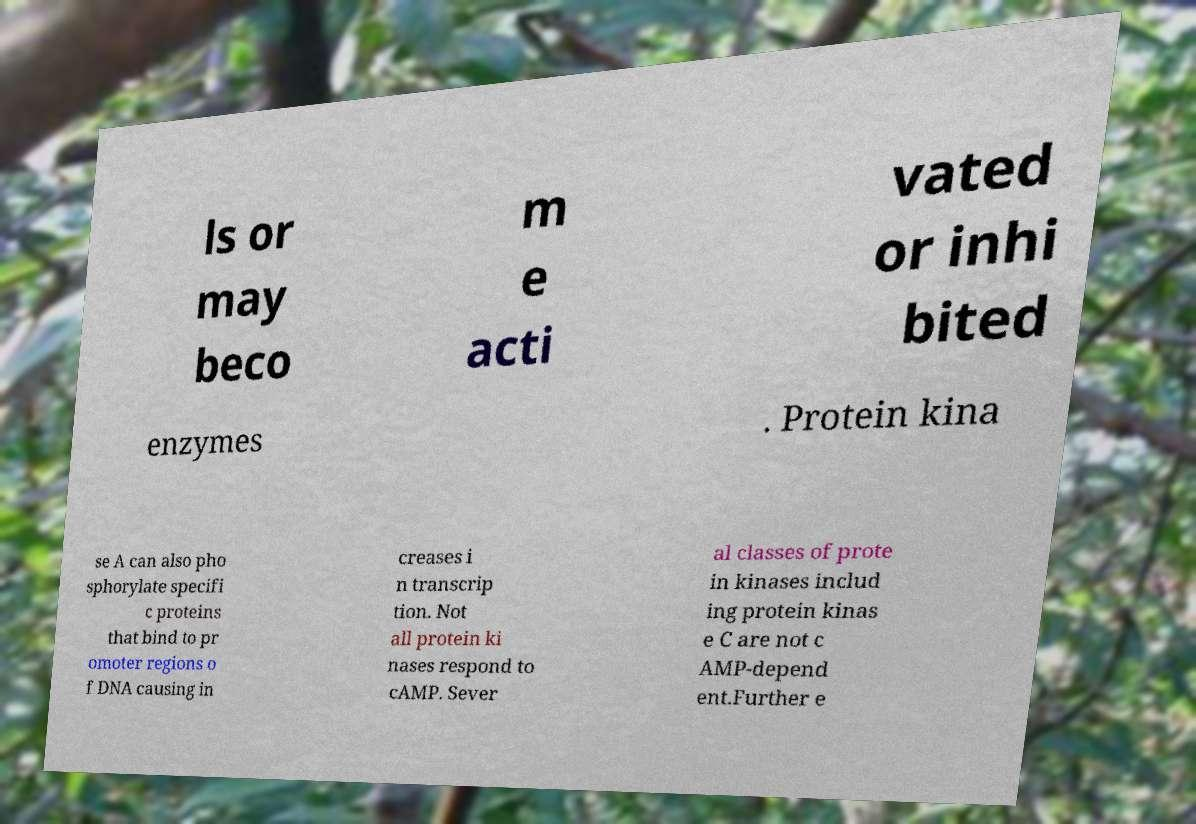I need the written content from this picture converted into text. Can you do that? ls or may beco m e acti vated or inhi bited enzymes . Protein kina se A can also pho sphorylate specifi c proteins that bind to pr omoter regions o f DNA causing in creases i n transcrip tion. Not all protein ki nases respond to cAMP. Sever al classes of prote in kinases includ ing protein kinas e C are not c AMP-depend ent.Further e 